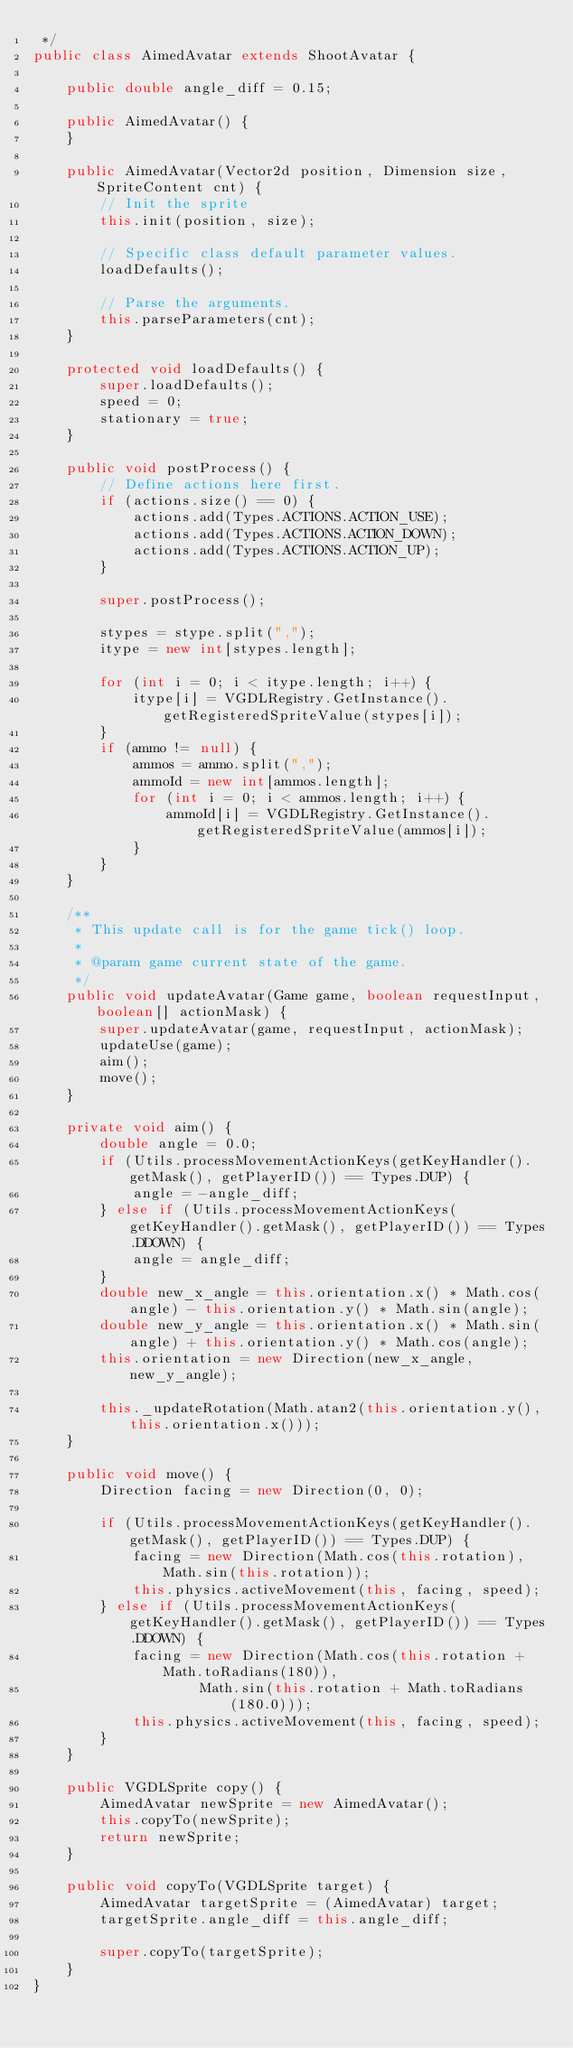<code> <loc_0><loc_0><loc_500><loc_500><_Java_> */
public class AimedAvatar extends ShootAvatar {

    public double angle_diff = 0.15;

    public AimedAvatar() {
    }

    public AimedAvatar(Vector2d position, Dimension size, SpriteContent cnt) {
        // Init the sprite
        this.init(position, size);

        // Specific class default parameter values.
        loadDefaults();

        // Parse the arguments.
        this.parseParameters(cnt);
    }

    protected void loadDefaults() {
        super.loadDefaults();
        speed = 0;
        stationary = true;
    }

    public void postProcess() {
        // Define actions here first.
        if (actions.size() == 0) {
            actions.add(Types.ACTIONS.ACTION_USE);
            actions.add(Types.ACTIONS.ACTION_DOWN);
            actions.add(Types.ACTIONS.ACTION_UP);
        }

        super.postProcess();

        stypes = stype.split(",");
        itype = new int[stypes.length];

        for (int i = 0; i < itype.length; i++) {
            itype[i] = VGDLRegistry.GetInstance().getRegisteredSpriteValue(stypes[i]);
        }
        if (ammo != null) {
            ammos = ammo.split(",");
            ammoId = new int[ammos.length];
            for (int i = 0; i < ammos.length; i++) {
                ammoId[i] = VGDLRegistry.GetInstance().getRegisteredSpriteValue(ammos[i]);
            }
        }
    }

    /**
     * This update call is for the game tick() loop.
     * 
     * @param game current state of the game.
     */
    public void updateAvatar(Game game, boolean requestInput, boolean[] actionMask) {
        super.updateAvatar(game, requestInput, actionMask);
        updateUse(game);
        aim();
        move();
    }

    private void aim() {
        double angle = 0.0;
        if (Utils.processMovementActionKeys(getKeyHandler().getMask(), getPlayerID()) == Types.DUP) {
            angle = -angle_diff;
        } else if (Utils.processMovementActionKeys(getKeyHandler().getMask(), getPlayerID()) == Types.DDOWN) {
            angle = angle_diff;
        }
        double new_x_angle = this.orientation.x() * Math.cos(angle) - this.orientation.y() * Math.sin(angle);
        double new_y_angle = this.orientation.x() * Math.sin(angle) + this.orientation.y() * Math.cos(angle);
        this.orientation = new Direction(new_x_angle, new_y_angle);

        this._updateRotation(Math.atan2(this.orientation.y(), this.orientation.x()));
    }

    public void move() {
        Direction facing = new Direction(0, 0);

        if (Utils.processMovementActionKeys(getKeyHandler().getMask(), getPlayerID()) == Types.DUP) {
            facing = new Direction(Math.cos(this.rotation), Math.sin(this.rotation));
            this.physics.activeMovement(this, facing, speed);
        } else if (Utils.processMovementActionKeys(getKeyHandler().getMask(), getPlayerID()) == Types.DDOWN) {
            facing = new Direction(Math.cos(this.rotation + Math.toRadians(180)),
                    Math.sin(this.rotation + Math.toRadians(180.0)));
            this.physics.activeMovement(this, facing, speed);
        }
    }

    public VGDLSprite copy() {
        AimedAvatar newSprite = new AimedAvatar();
        this.copyTo(newSprite);
        return newSprite;
    }

    public void copyTo(VGDLSprite target) {
        AimedAvatar targetSprite = (AimedAvatar) target;
        targetSprite.angle_diff = this.angle_diff;

        super.copyTo(targetSprite);
    }
}
</code> 